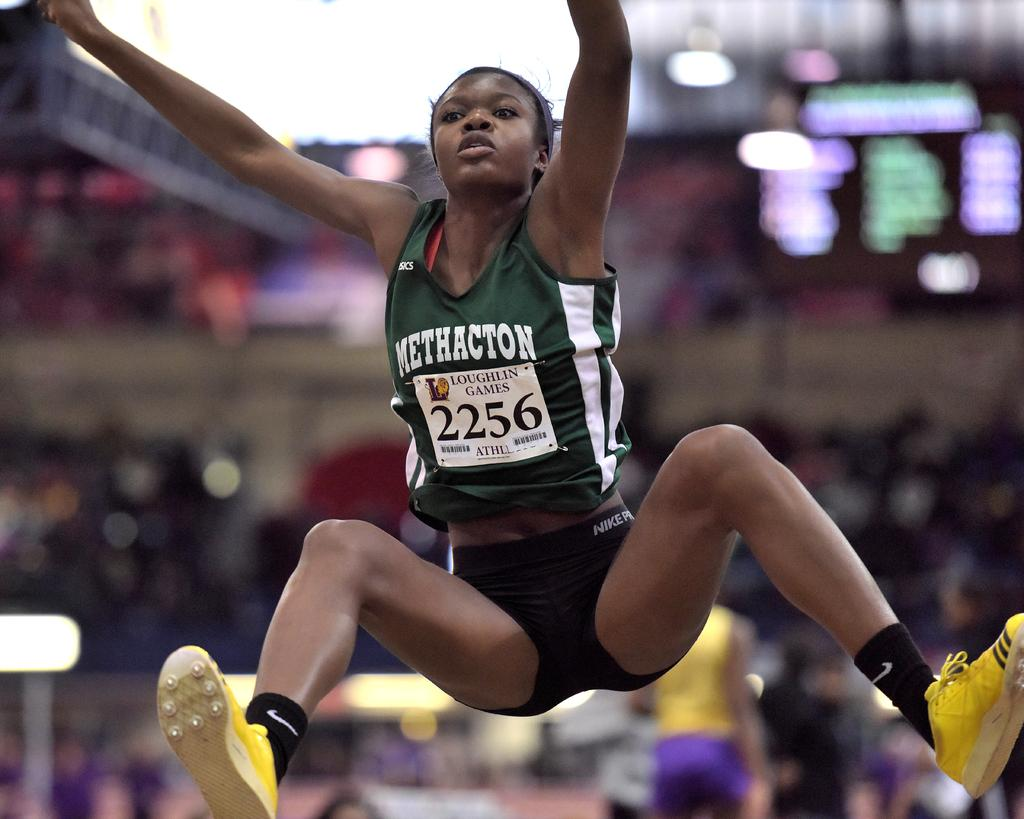<image>
Render a clear and concise summary of the photo. woman wearing green methacton jersey at loughlin games jumping 